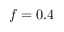<formula> <loc_0><loc_0><loc_500><loc_500>f = 0 . 4</formula> 